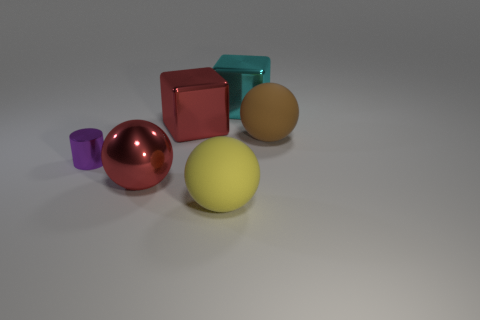Add 2 small cyan metal balls. How many objects exist? 8 Subtract all cyan cubes. How many cubes are left? 1 Subtract all big brown spheres. How many spheres are left? 2 Subtract 0 gray cubes. How many objects are left? 6 Subtract all cubes. How many objects are left? 4 Subtract 1 cylinders. How many cylinders are left? 0 Subtract all red cylinders. Subtract all yellow cubes. How many cylinders are left? 1 Subtract all gray blocks. How many yellow spheres are left? 1 Subtract all shiny cylinders. Subtract all purple objects. How many objects are left? 4 Add 2 small cylinders. How many small cylinders are left? 3 